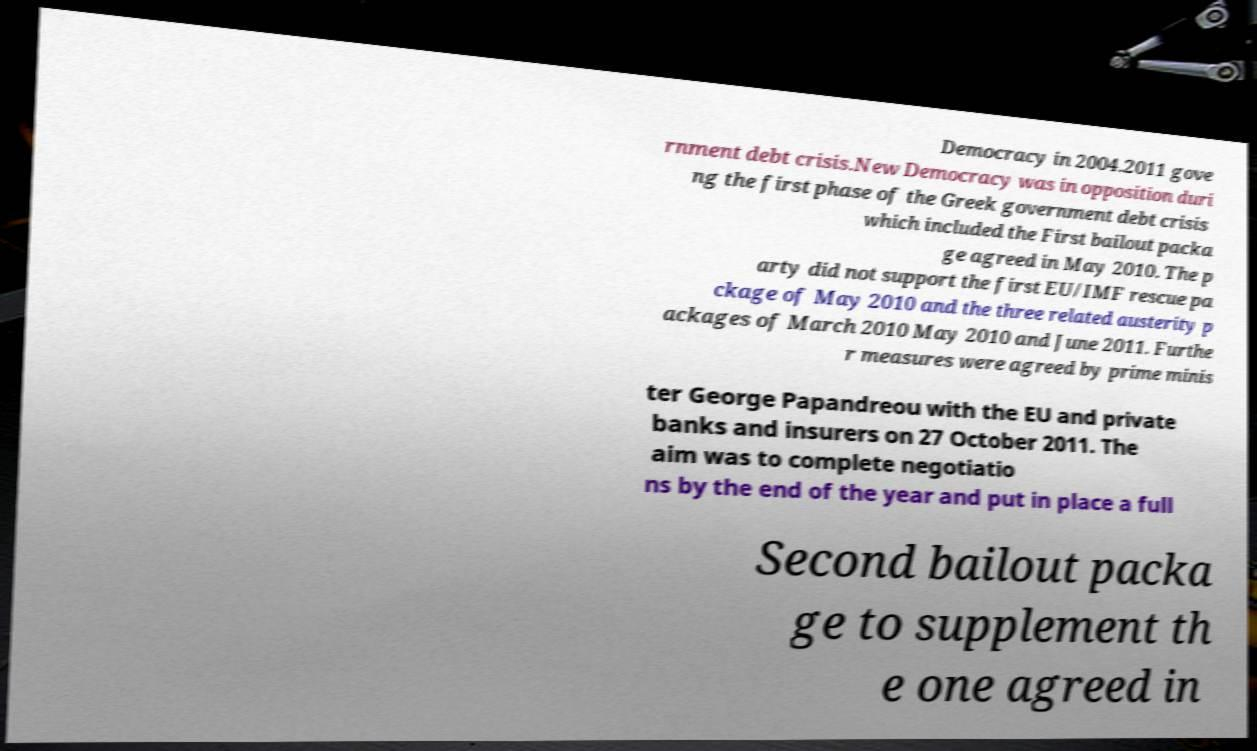Please read and relay the text visible in this image. What does it say? Democracy in 2004.2011 gove rnment debt crisis.New Democracy was in opposition duri ng the first phase of the Greek government debt crisis which included the First bailout packa ge agreed in May 2010. The p arty did not support the first EU/IMF rescue pa ckage of May 2010 and the three related austerity p ackages of March 2010 May 2010 and June 2011. Furthe r measures were agreed by prime minis ter George Papandreou with the EU and private banks and insurers on 27 October 2011. The aim was to complete negotiatio ns by the end of the year and put in place a full Second bailout packa ge to supplement th e one agreed in 